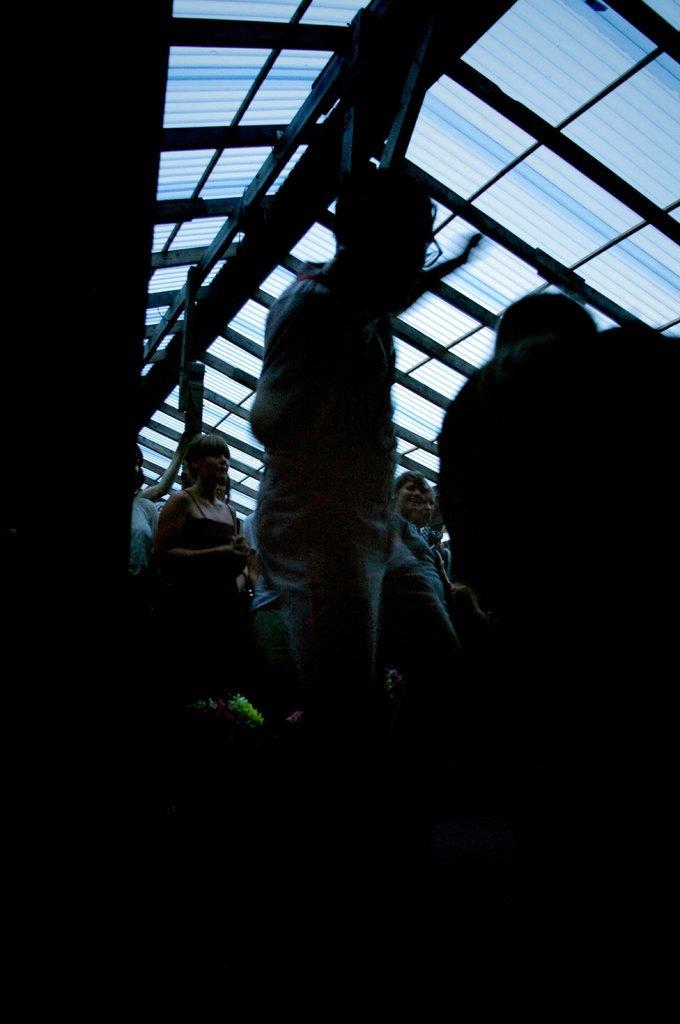How would you summarize this image in a sentence or two? At the bottom the image is dark but we can see few persons are standing. There are poles on the glass roof. 